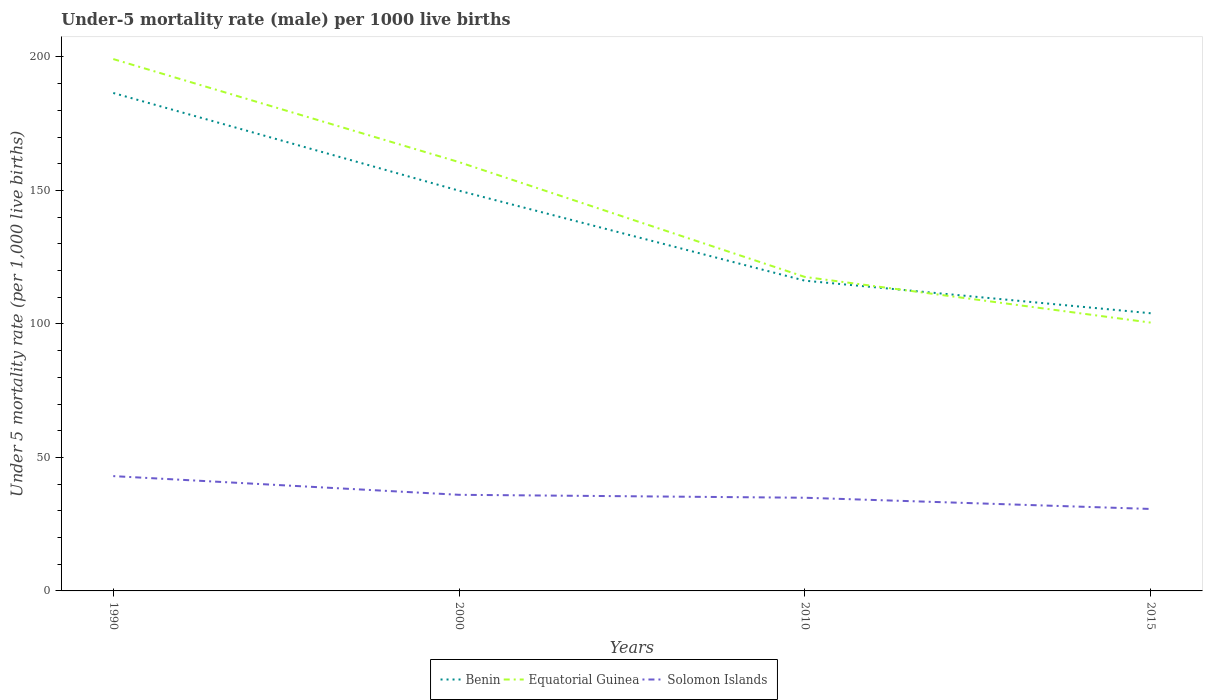Is the number of lines equal to the number of legend labels?
Make the answer very short. Yes. Across all years, what is the maximum under-five mortality rate in Benin?
Make the answer very short. 104. In which year was the under-five mortality rate in Solomon Islands maximum?
Your answer should be compact. 2015. What is the total under-five mortality rate in Benin in the graph?
Offer a terse response. 82.5. What is the difference between the highest and the second highest under-five mortality rate in Equatorial Guinea?
Your response must be concise. 98.7. How many lines are there?
Provide a succinct answer. 3. Does the graph contain any zero values?
Your answer should be very brief. No. Does the graph contain grids?
Your response must be concise. No. Where does the legend appear in the graph?
Your answer should be very brief. Bottom center. How many legend labels are there?
Your answer should be compact. 3. How are the legend labels stacked?
Keep it short and to the point. Horizontal. What is the title of the graph?
Keep it short and to the point. Under-5 mortality rate (male) per 1000 live births. What is the label or title of the X-axis?
Your answer should be compact. Years. What is the label or title of the Y-axis?
Ensure brevity in your answer.  Under 5 mortality rate (per 1,0 live births). What is the Under 5 mortality rate (per 1,000 live births) of Benin in 1990?
Provide a short and direct response. 186.5. What is the Under 5 mortality rate (per 1,000 live births) in Equatorial Guinea in 1990?
Your response must be concise. 199.2. What is the Under 5 mortality rate (per 1,000 live births) of Benin in 2000?
Make the answer very short. 149.9. What is the Under 5 mortality rate (per 1,000 live births) in Equatorial Guinea in 2000?
Offer a very short reply. 160.6. What is the Under 5 mortality rate (per 1,000 live births) in Solomon Islands in 2000?
Keep it short and to the point. 36. What is the Under 5 mortality rate (per 1,000 live births) of Benin in 2010?
Offer a very short reply. 116.2. What is the Under 5 mortality rate (per 1,000 live births) in Equatorial Guinea in 2010?
Ensure brevity in your answer.  117.6. What is the Under 5 mortality rate (per 1,000 live births) in Solomon Islands in 2010?
Provide a short and direct response. 34.9. What is the Under 5 mortality rate (per 1,000 live births) in Benin in 2015?
Make the answer very short. 104. What is the Under 5 mortality rate (per 1,000 live births) in Equatorial Guinea in 2015?
Ensure brevity in your answer.  100.5. What is the Under 5 mortality rate (per 1,000 live births) in Solomon Islands in 2015?
Ensure brevity in your answer.  30.7. Across all years, what is the maximum Under 5 mortality rate (per 1,000 live births) in Benin?
Give a very brief answer. 186.5. Across all years, what is the maximum Under 5 mortality rate (per 1,000 live births) of Equatorial Guinea?
Ensure brevity in your answer.  199.2. Across all years, what is the maximum Under 5 mortality rate (per 1,000 live births) in Solomon Islands?
Provide a succinct answer. 43. Across all years, what is the minimum Under 5 mortality rate (per 1,000 live births) of Benin?
Provide a succinct answer. 104. Across all years, what is the minimum Under 5 mortality rate (per 1,000 live births) in Equatorial Guinea?
Offer a terse response. 100.5. Across all years, what is the minimum Under 5 mortality rate (per 1,000 live births) in Solomon Islands?
Make the answer very short. 30.7. What is the total Under 5 mortality rate (per 1,000 live births) of Benin in the graph?
Your answer should be compact. 556.6. What is the total Under 5 mortality rate (per 1,000 live births) of Equatorial Guinea in the graph?
Offer a very short reply. 577.9. What is the total Under 5 mortality rate (per 1,000 live births) of Solomon Islands in the graph?
Ensure brevity in your answer.  144.6. What is the difference between the Under 5 mortality rate (per 1,000 live births) of Benin in 1990 and that in 2000?
Your answer should be very brief. 36.6. What is the difference between the Under 5 mortality rate (per 1,000 live births) in Equatorial Guinea in 1990 and that in 2000?
Offer a very short reply. 38.6. What is the difference between the Under 5 mortality rate (per 1,000 live births) of Solomon Islands in 1990 and that in 2000?
Provide a short and direct response. 7. What is the difference between the Under 5 mortality rate (per 1,000 live births) of Benin in 1990 and that in 2010?
Provide a succinct answer. 70.3. What is the difference between the Under 5 mortality rate (per 1,000 live births) of Equatorial Guinea in 1990 and that in 2010?
Your answer should be very brief. 81.6. What is the difference between the Under 5 mortality rate (per 1,000 live births) of Benin in 1990 and that in 2015?
Your answer should be compact. 82.5. What is the difference between the Under 5 mortality rate (per 1,000 live births) in Equatorial Guinea in 1990 and that in 2015?
Keep it short and to the point. 98.7. What is the difference between the Under 5 mortality rate (per 1,000 live births) of Solomon Islands in 1990 and that in 2015?
Offer a very short reply. 12.3. What is the difference between the Under 5 mortality rate (per 1,000 live births) in Benin in 2000 and that in 2010?
Make the answer very short. 33.7. What is the difference between the Under 5 mortality rate (per 1,000 live births) in Benin in 2000 and that in 2015?
Your response must be concise. 45.9. What is the difference between the Under 5 mortality rate (per 1,000 live births) of Equatorial Guinea in 2000 and that in 2015?
Offer a terse response. 60.1. What is the difference between the Under 5 mortality rate (per 1,000 live births) in Equatorial Guinea in 2010 and that in 2015?
Your answer should be compact. 17.1. What is the difference between the Under 5 mortality rate (per 1,000 live births) of Solomon Islands in 2010 and that in 2015?
Your response must be concise. 4.2. What is the difference between the Under 5 mortality rate (per 1,000 live births) in Benin in 1990 and the Under 5 mortality rate (per 1,000 live births) in Equatorial Guinea in 2000?
Make the answer very short. 25.9. What is the difference between the Under 5 mortality rate (per 1,000 live births) of Benin in 1990 and the Under 5 mortality rate (per 1,000 live births) of Solomon Islands in 2000?
Your answer should be very brief. 150.5. What is the difference between the Under 5 mortality rate (per 1,000 live births) of Equatorial Guinea in 1990 and the Under 5 mortality rate (per 1,000 live births) of Solomon Islands in 2000?
Ensure brevity in your answer.  163.2. What is the difference between the Under 5 mortality rate (per 1,000 live births) in Benin in 1990 and the Under 5 mortality rate (per 1,000 live births) in Equatorial Guinea in 2010?
Give a very brief answer. 68.9. What is the difference between the Under 5 mortality rate (per 1,000 live births) in Benin in 1990 and the Under 5 mortality rate (per 1,000 live births) in Solomon Islands in 2010?
Ensure brevity in your answer.  151.6. What is the difference between the Under 5 mortality rate (per 1,000 live births) of Equatorial Guinea in 1990 and the Under 5 mortality rate (per 1,000 live births) of Solomon Islands in 2010?
Your answer should be compact. 164.3. What is the difference between the Under 5 mortality rate (per 1,000 live births) of Benin in 1990 and the Under 5 mortality rate (per 1,000 live births) of Equatorial Guinea in 2015?
Your answer should be very brief. 86. What is the difference between the Under 5 mortality rate (per 1,000 live births) of Benin in 1990 and the Under 5 mortality rate (per 1,000 live births) of Solomon Islands in 2015?
Give a very brief answer. 155.8. What is the difference between the Under 5 mortality rate (per 1,000 live births) of Equatorial Guinea in 1990 and the Under 5 mortality rate (per 1,000 live births) of Solomon Islands in 2015?
Keep it short and to the point. 168.5. What is the difference between the Under 5 mortality rate (per 1,000 live births) of Benin in 2000 and the Under 5 mortality rate (per 1,000 live births) of Equatorial Guinea in 2010?
Your answer should be compact. 32.3. What is the difference between the Under 5 mortality rate (per 1,000 live births) of Benin in 2000 and the Under 5 mortality rate (per 1,000 live births) of Solomon Islands in 2010?
Offer a very short reply. 115. What is the difference between the Under 5 mortality rate (per 1,000 live births) of Equatorial Guinea in 2000 and the Under 5 mortality rate (per 1,000 live births) of Solomon Islands in 2010?
Provide a short and direct response. 125.7. What is the difference between the Under 5 mortality rate (per 1,000 live births) in Benin in 2000 and the Under 5 mortality rate (per 1,000 live births) in Equatorial Guinea in 2015?
Your answer should be very brief. 49.4. What is the difference between the Under 5 mortality rate (per 1,000 live births) in Benin in 2000 and the Under 5 mortality rate (per 1,000 live births) in Solomon Islands in 2015?
Give a very brief answer. 119.2. What is the difference between the Under 5 mortality rate (per 1,000 live births) in Equatorial Guinea in 2000 and the Under 5 mortality rate (per 1,000 live births) in Solomon Islands in 2015?
Give a very brief answer. 129.9. What is the difference between the Under 5 mortality rate (per 1,000 live births) in Benin in 2010 and the Under 5 mortality rate (per 1,000 live births) in Equatorial Guinea in 2015?
Your answer should be compact. 15.7. What is the difference between the Under 5 mortality rate (per 1,000 live births) in Benin in 2010 and the Under 5 mortality rate (per 1,000 live births) in Solomon Islands in 2015?
Your answer should be very brief. 85.5. What is the difference between the Under 5 mortality rate (per 1,000 live births) in Equatorial Guinea in 2010 and the Under 5 mortality rate (per 1,000 live births) in Solomon Islands in 2015?
Offer a terse response. 86.9. What is the average Under 5 mortality rate (per 1,000 live births) in Benin per year?
Give a very brief answer. 139.15. What is the average Under 5 mortality rate (per 1,000 live births) in Equatorial Guinea per year?
Offer a terse response. 144.47. What is the average Under 5 mortality rate (per 1,000 live births) in Solomon Islands per year?
Provide a succinct answer. 36.15. In the year 1990, what is the difference between the Under 5 mortality rate (per 1,000 live births) of Benin and Under 5 mortality rate (per 1,000 live births) of Equatorial Guinea?
Your response must be concise. -12.7. In the year 1990, what is the difference between the Under 5 mortality rate (per 1,000 live births) of Benin and Under 5 mortality rate (per 1,000 live births) of Solomon Islands?
Keep it short and to the point. 143.5. In the year 1990, what is the difference between the Under 5 mortality rate (per 1,000 live births) in Equatorial Guinea and Under 5 mortality rate (per 1,000 live births) in Solomon Islands?
Ensure brevity in your answer.  156.2. In the year 2000, what is the difference between the Under 5 mortality rate (per 1,000 live births) of Benin and Under 5 mortality rate (per 1,000 live births) of Solomon Islands?
Your answer should be very brief. 113.9. In the year 2000, what is the difference between the Under 5 mortality rate (per 1,000 live births) of Equatorial Guinea and Under 5 mortality rate (per 1,000 live births) of Solomon Islands?
Your response must be concise. 124.6. In the year 2010, what is the difference between the Under 5 mortality rate (per 1,000 live births) in Benin and Under 5 mortality rate (per 1,000 live births) in Equatorial Guinea?
Your answer should be compact. -1.4. In the year 2010, what is the difference between the Under 5 mortality rate (per 1,000 live births) in Benin and Under 5 mortality rate (per 1,000 live births) in Solomon Islands?
Provide a short and direct response. 81.3. In the year 2010, what is the difference between the Under 5 mortality rate (per 1,000 live births) of Equatorial Guinea and Under 5 mortality rate (per 1,000 live births) of Solomon Islands?
Give a very brief answer. 82.7. In the year 2015, what is the difference between the Under 5 mortality rate (per 1,000 live births) of Benin and Under 5 mortality rate (per 1,000 live births) of Equatorial Guinea?
Your answer should be very brief. 3.5. In the year 2015, what is the difference between the Under 5 mortality rate (per 1,000 live births) in Benin and Under 5 mortality rate (per 1,000 live births) in Solomon Islands?
Your answer should be very brief. 73.3. In the year 2015, what is the difference between the Under 5 mortality rate (per 1,000 live births) of Equatorial Guinea and Under 5 mortality rate (per 1,000 live births) of Solomon Islands?
Your response must be concise. 69.8. What is the ratio of the Under 5 mortality rate (per 1,000 live births) of Benin in 1990 to that in 2000?
Keep it short and to the point. 1.24. What is the ratio of the Under 5 mortality rate (per 1,000 live births) in Equatorial Guinea in 1990 to that in 2000?
Your answer should be very brief. 1.24. What is the ratio of the Under 5 mortality rate (per 1,000 live births) of Solomon Islands in 1990 to that in 2000?
Make the answer very short. 1.19. What is the ratio of the Under 5 mortality rate (per 1,000 live births) of Benin in 1990 to that in 2010?
Offer a terse response. 1.6. What is the ratio of the Under 5 mortality rate (per 1,000 live births) of Equatorial Guinea in 1990 to that in 2010?
Offer a very short reply. 1.69. What is the ratio of the Under 5 mortality rate (per 1,000 live births) in Solomon Islands in 1990 to that in 2010?
Provide a succinct answer. 1.23. What is the ratio of the Under 5 mortality rate (per 1,000 live births) in Benin in 1990 to that in 2015?
Keep it short and to the point. 1.79. What is the ratio of the Under 5 mortality rate (per 1,000 live births) in Equatorial Guinea in 1990 to that in 2015?
Provide a succinct answer. 1.98. What is the ratio of the Under 5 mortality rate (per 1,000 live births) in Solomon Islands in 1990 to that in 2015?
Your answer should be compact. 1.4. What is the ratio of the Under 5 mortality rate (per 1,000 live births) in Benin in 2000 to that in 2010?
Your answer should be very brief. 1.29. What is the ratio of the Under 5 mortality rate (per 1,000 live births) of Equatorial Guinea in 2000 to that in 2010?
Provide a short and direct response. 1.37. What is the ratio of the Under 5 mortality rate (per 1,000 live births) in Solomon Islands in 2000 to that in 2010?
Ensure brevity in your answer.  1.03. What is the ratio of the Under 5 mortality rate (per 1,000 live births) in Benin in 2000 to that in 2015?
Provide a succinct answer. 1.44. What is the ratio of the Under 5 mortality rate (per 1,000 live births) of Equatorial Guinea in 2000 to that in 2015?
Offer a terse response. 1.6. What is the ratio of the Under 5 mortality rate (per 1,000 live births) in Solomon Islands in 2000 to that in 2015?
Offer a terse response. 1.17. What is the ratio of the Under 5 mortality rate (per 1,000 live births) in Benin in 2010 to that in 2015?
Offer a terse response. 1.12. What is the ratio of the Under 5 mortality rate (per 1,000 live births) of Equatorial Guinea in 2010 to that in 2015?
Provide a succinct answer. 1.17. What is the ratio of the Under 5 mortality rate (per 1,000 live births) in Solomon Islands in 2010 to that in 2015?
Provide a succinct answer. 1.14. What is the difference between the highest and the second highest Under 5 mortality rate (per 1,000 live births) of Benin?
Your answer should be compact. 36.6. What is the difference between the highest and the second highest Under 5 mortality rate (per 1,000 live births) of Equatorial Guinea?
Provide a succinct answer. 38.6. What is the difference between the highest and the lowest Under 5 mortality rate (per 1,000 live births) of Benin?
Your answer should be very brief. 82.5. What is the difference between the highest and the lowest Under 5 mortality rate (per 1,000 live births) in Equatorial Guinea?
Your answer should be very brief. 98.7. What is the difference between the highest and the lowest Under 5 mortality rate (per 1,000 live births) in Solomon Islands?
Your response must be concise. 12.3. 